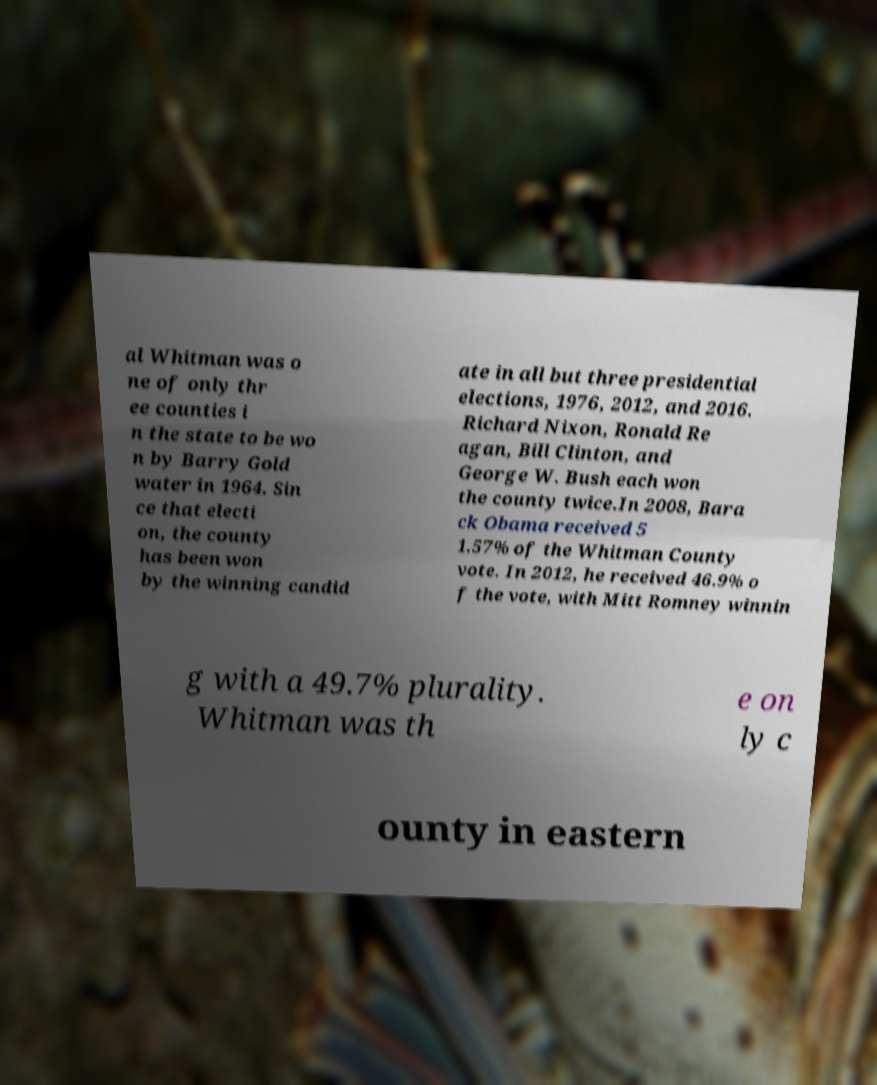Could you assist in decoding the text presented in this image and type it out clearly? al Whitman was o ne of only thr ee counties i n the state to be wo n by Barry Gold water in 1964. Sin ce that electi on, the county has been won by the winning candid ate in all but three presidential elections, 1976, 2012, and 2016. Richard Nixon, Ronald Re agan, Bill Clinton, and George W. Bush each won the county twice.In 2008, Bara ck Obama received 5 1.57% of the Whitman County vote. In 2012, he received 46.9% o f the vote, with Mitt Romney winnin g with a 49.7% plurality. Whitman was th e on ly c ounty in eastern 